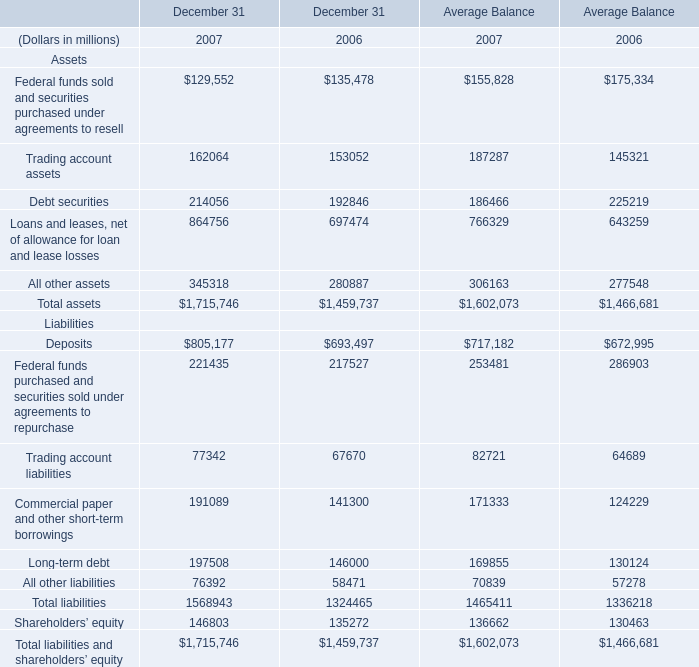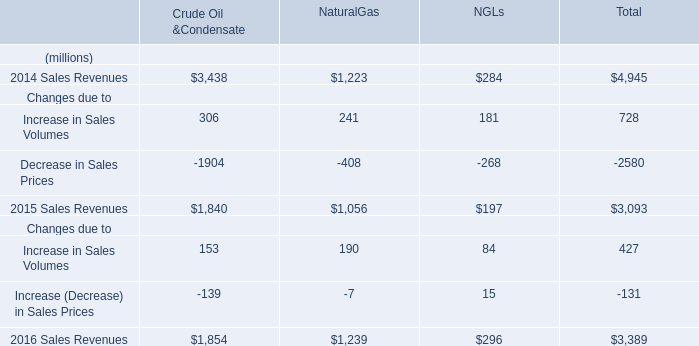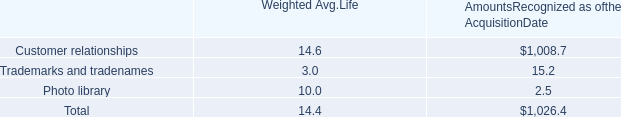what's the total amount of Debt securities of December 31 2006, and Customer relationships of AmountsRecognized as ofthe AcquisitionDate ? 
Computations: (192846.0 + 1008.7)
Answer: 193854.7. 